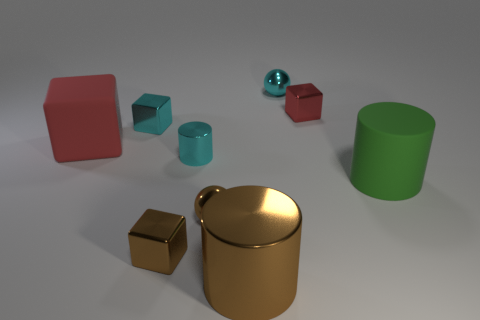The large cylinder that is made of the same material as the large block is what color?
Your answer should be very brief. Green. Is the number of tiny cyan things greater than the number of tiny brown objects?
Make the answer very short. Yes. What number of things are small cubes that are behind the large green matte cylinder or tiny cyan balls?
Offer a terse response. 3. Is there a purple shiny ball of the same size as the matte cube?
Offer a terse response. No. Is the number of green rubber things less than the number of tiny cubes?
Ensure brevity in your answer.  Yes. How many cubes are brown metallic objects or rubber objects?
Ensure brevity in your answer.  2. How many metallic objects are the same color as the large rubber block?
Keep it short and to the point. 1. What is the size of the metallic object that is to the left of the big metallic object and behind the big red rubber block?
Provide a short and direct response. Small. Is the number of matte objects on the left side of the tiny cyan metallic cube less than the number of big red rubber cubes?
Keep it short and to the point. No. Are the big green object and the small cyan sphere made of the same material?
Your answer should be compact. No. 